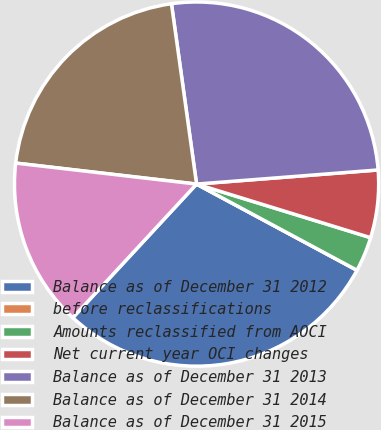Convert chart to OTSL. <chart><loc_0><loc_0><loc_500><loc_500><pie_chart><fcel>Balance as of December 31 2012<fcel>before reclassifications<fcel>Amounts reclassified from AOCI<fcel>Net current year OCI changes<fcel>Balance as of December 31 2013<fcel>Balance as of December 31 2014<fcel>Balance as of December 31 2015<nl><fcel>29.05%<fcel>0.0%<fcel>3.09%<fcel>5.99%<fcel>25.97%<fcel>20.96%<fcel>14.95%<nl></chart> 